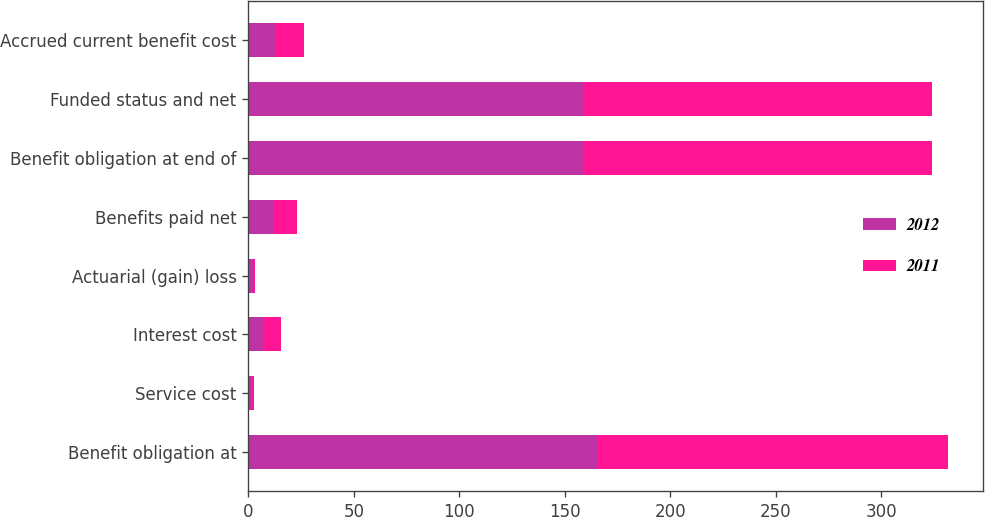Convert chart to OTSL. <chart><loc_0><loc_0><loc_500><loc_500><stacked_bar_chart><ecel><fcel>Benefit obligation at<fcel>Service cost<fcel>Interest cost<fcel>Actuarial (gain) loss<fcel>Benefits paid net<fcel>Benefit obligation at end of<fcel>Funded status and net<fcel>Accrued current benefit cost<nl><fcel>2012<fcel>165.2<fcel>1.3<fcel>7.1<fcel>2.9<fcel>11.9<fcel>158.8<fcel>158.8<fcel>12.9<nl><fcel>2011<fcel>166.5<fcel>1.3<fcel>8.3<fcel>0.3<fcel>11.2<fcel>165.2<fcel>165.2<fcel>13.6<nl></chart> 